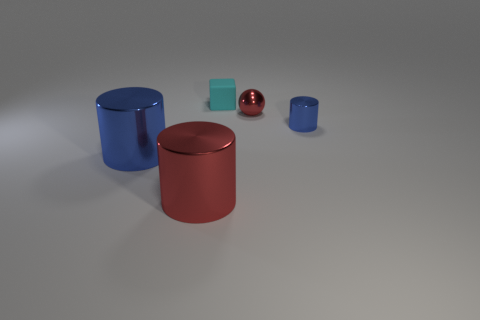Is the shape of the cyan rubber thing the same as the blue thing that is in front of the small blue thing?
Ensure brevity in your answer.  No. What number of other things are there of the same shape as the large red thing?
Offer a terse response. 2. There is a shiny object that is left of the tiny cylinder and on the right side of the large red cylinder; what color is it?
Provide a succinct answer. Red. What color is the tiny matte thing?
Make the answer very short. Cyan. Is the red sphere made of the same material as the blue cylinder that is left of the tiny cylinder?
Make the answer very short. Yes. There is another tiny thing that is the same material as the small blue thing; what shape is it?
Your answer should be very brief. Sphere. What color is the sphere that is the same size as the block?
Offer a very short reply. Red. There is a red object to the left of the cyan rubber cube; does it have the same size as the big blue shiny object?
Your answer should be very brief. Yes. Is the tiny cylinder the same color as the matte block?
Provide a succinct answer. No. What number of gray things are there?
Your answer should be compact. 0. 